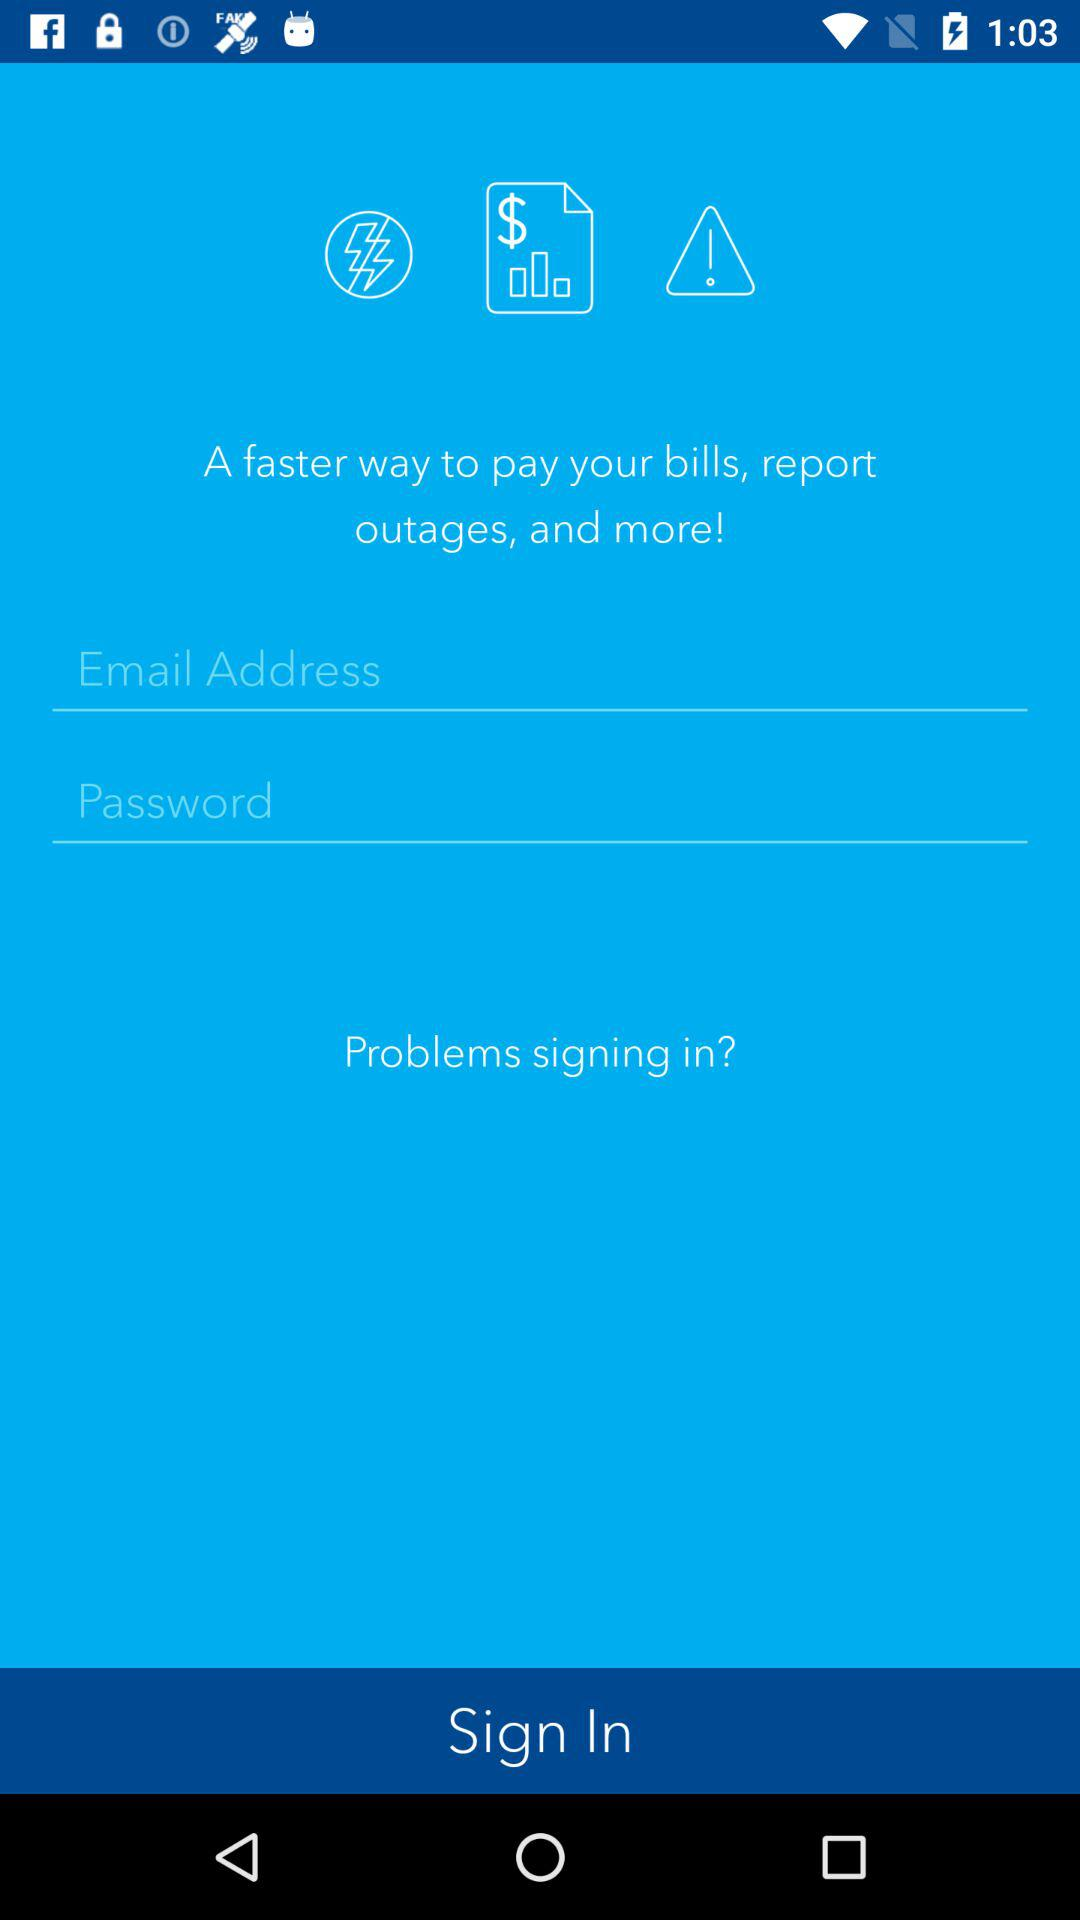How many fields are there in the login form?
Answer the question using a single word or phrase. 2 